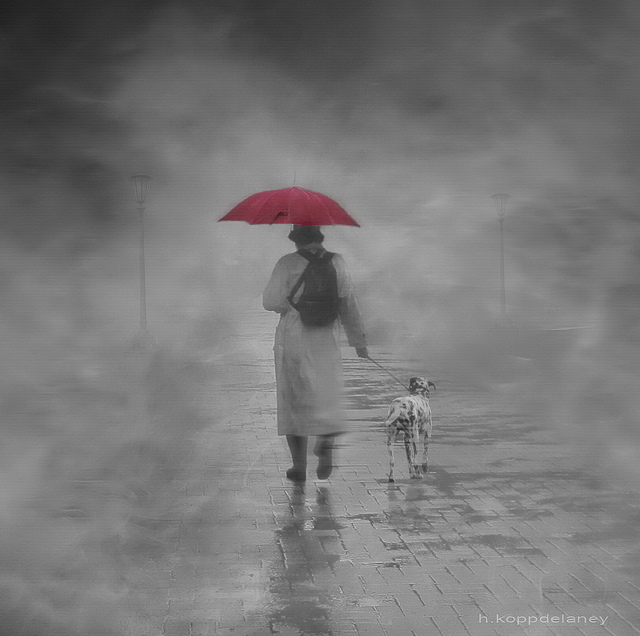Read and extract the text from this image. koppdelaney 